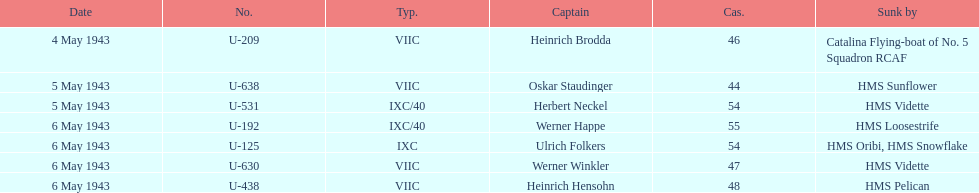How many captains are listed? 7. 